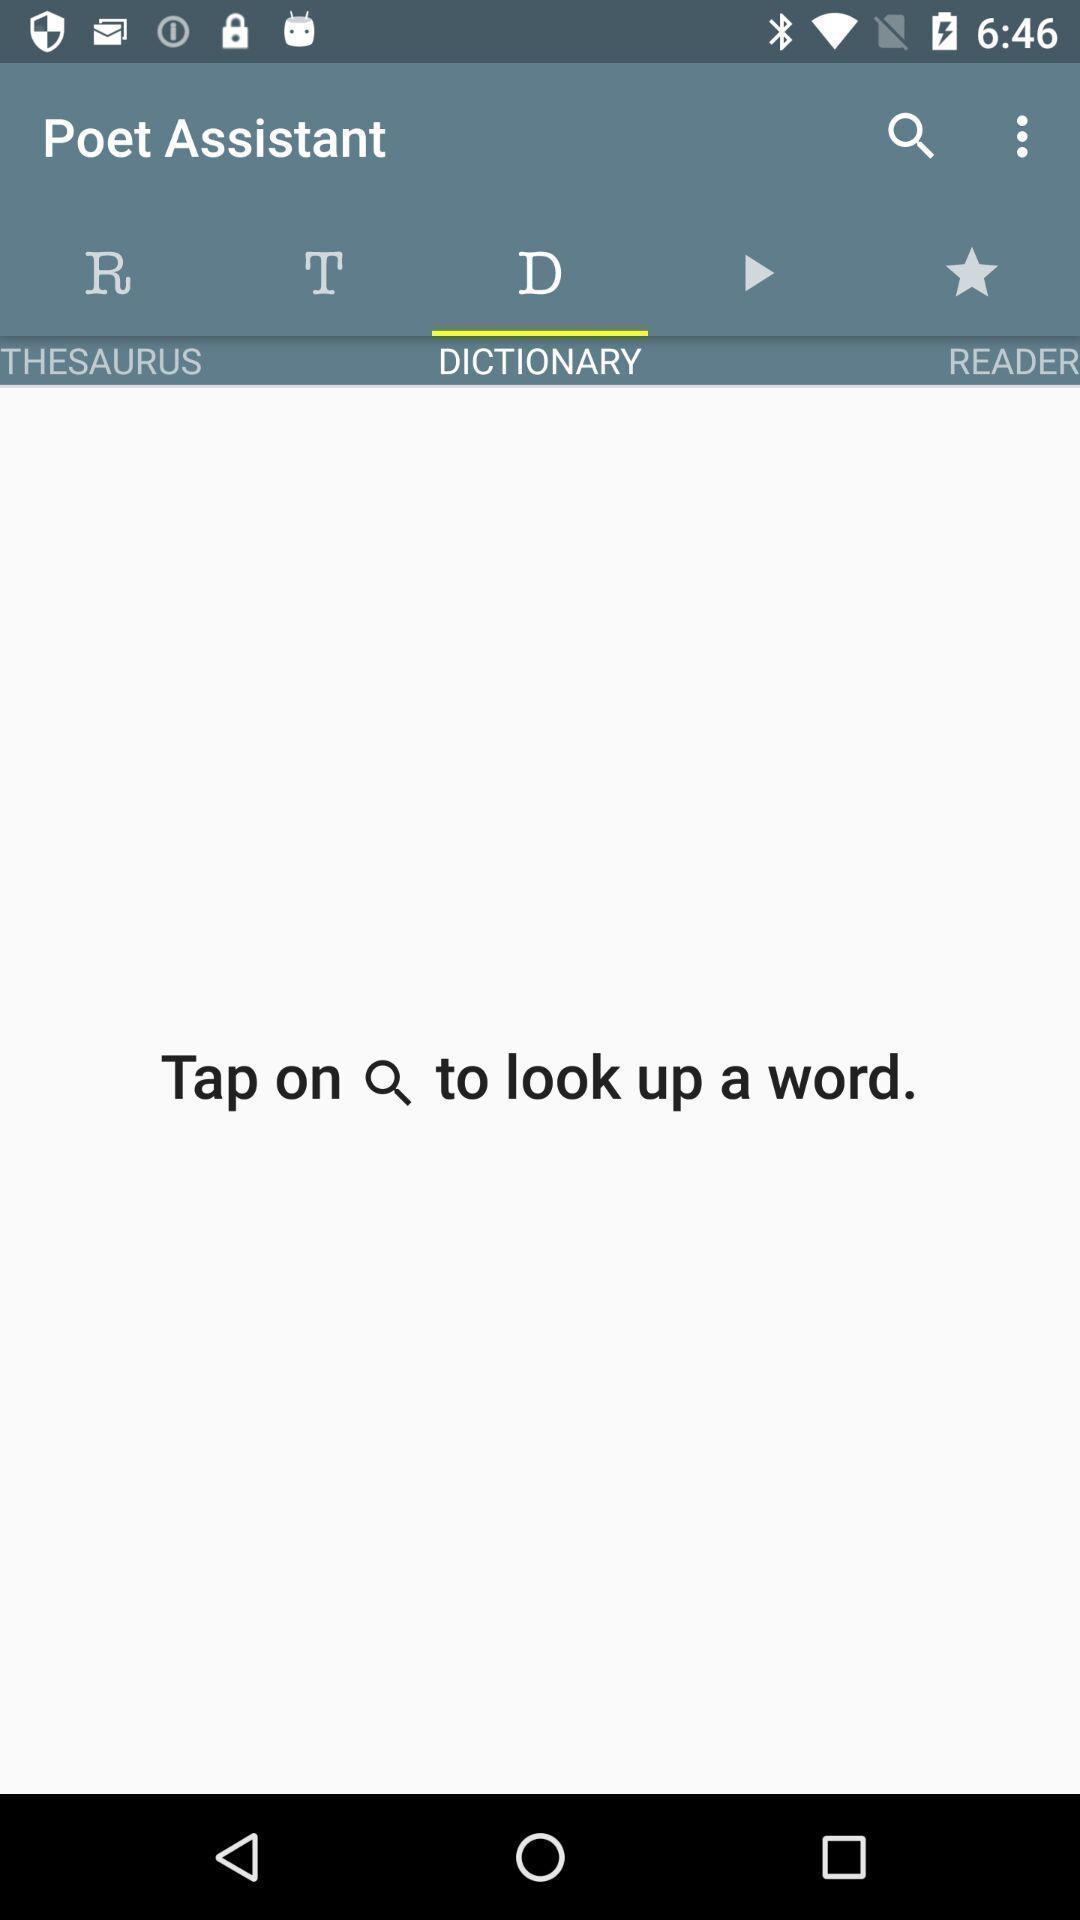Summarize the main components in this picture. Search bar to find different words. 